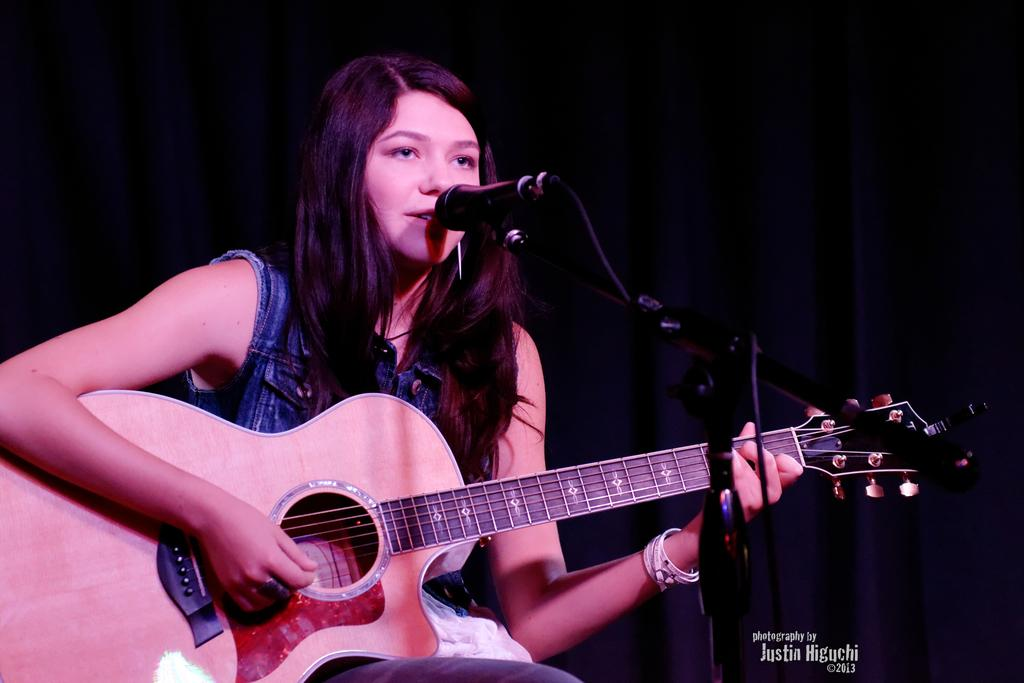What is the woman in the image doing? The woman is playing a guitar and singing a song. What object is the woman using to amplify her voice? There is a microphone in the image. How is the microphone positioned in the image? There is a microphone stand in the image. What type of volleyball is the woman using as a prop in the image? There is no volleyball present in the image. How does the woman use the brake while playing the guitar in the image? The woman is not using a brake in the image, as she is playing a guitar and singing a song. 